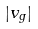Convert formula to latex. <formula><loc_0><loc_0><loc_500><loc_500>| v _ { g } |</formula> 